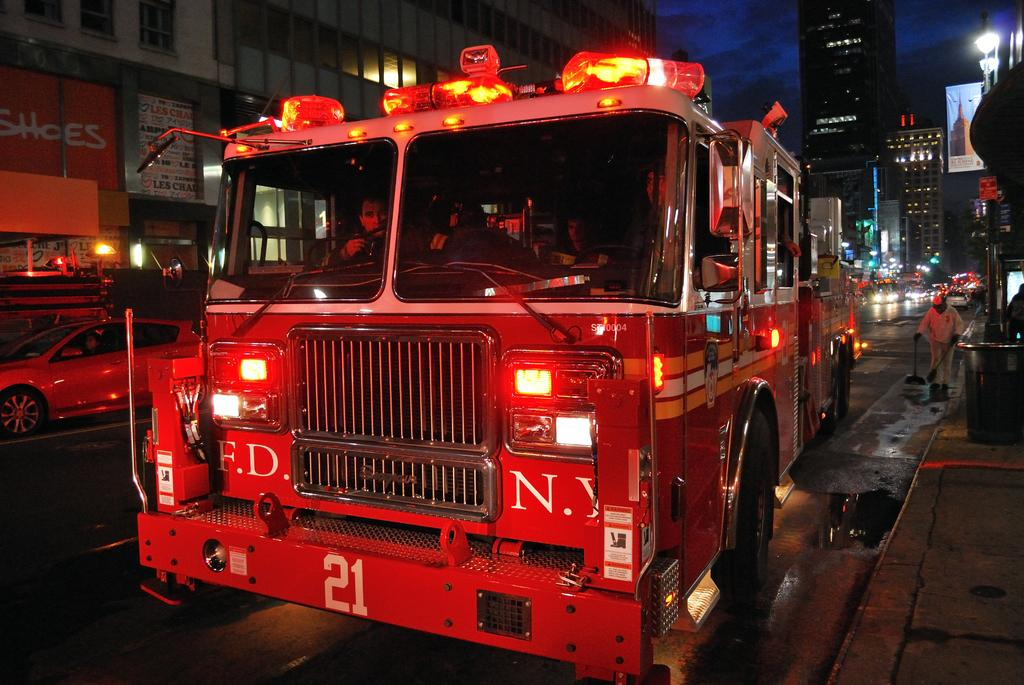What can be seen on the road in the image? There are vehicles on the road in the image. What type of structures are visible in the image? There are buildings with windows in the image. What additional items can be seen in the image? There are posters and poles in the image. What else is present in the image? There are lights and people in the image. What is visible in the background of the image? The sky is visible in the background of the image. What type of cheese is being served on the stage in the image? There is no cheese or stage present in the image. Can you describe the bee's role in the image? There are no bees present in the image. 